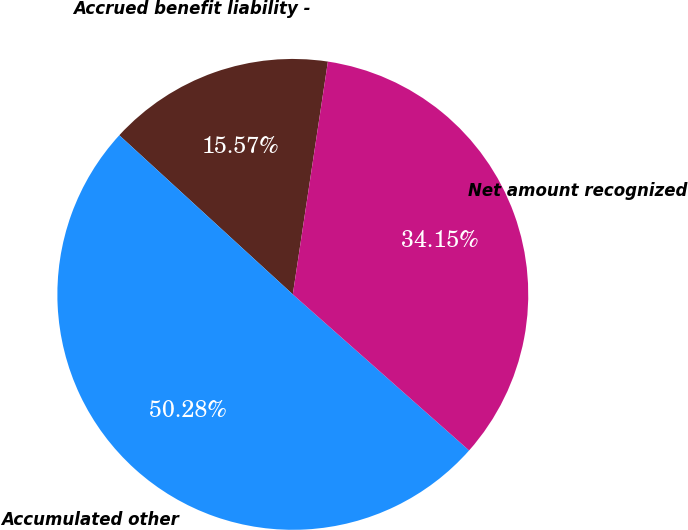<chart> <loc_0><loc_0><loc_500><loc_500><pie_chart><fcel>Accrued benefit liability -<fcel>Accumulated other<fcel>Net amount recognized<nl><fcel>15.57%<fcel>50.28%<fcel>34.15%<nl></chart> 